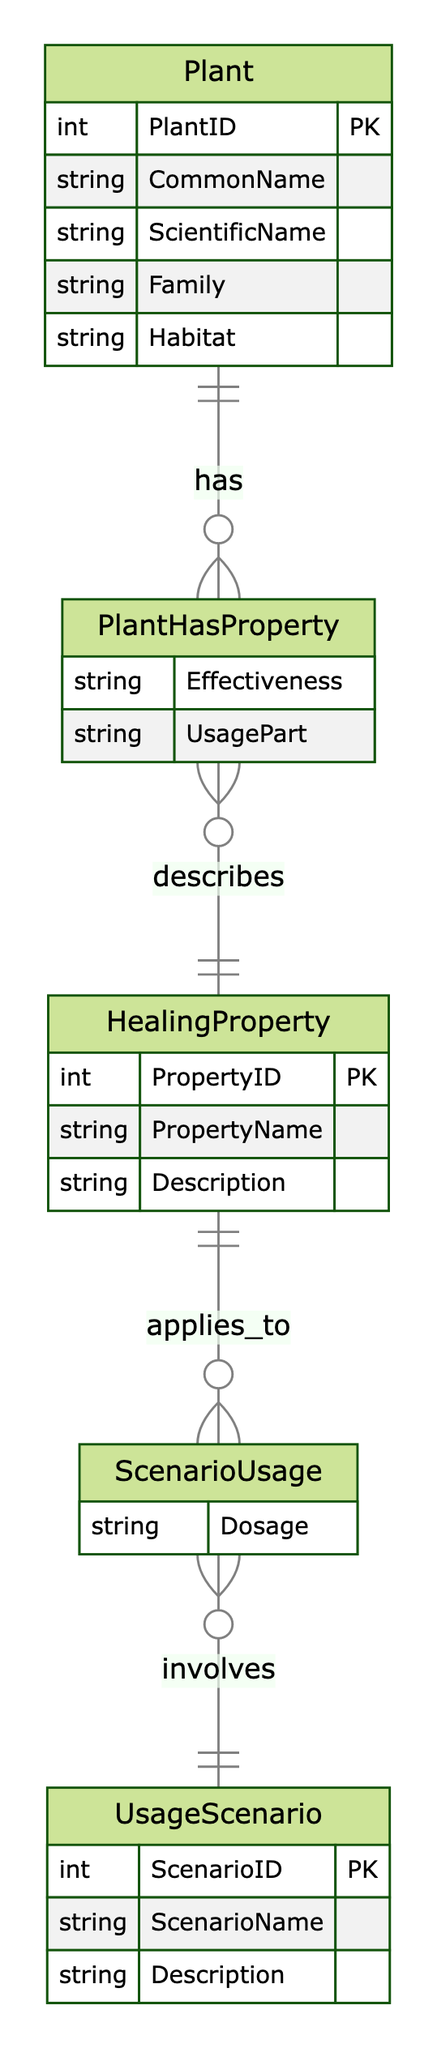What are the entities in this diagram? The diagram consists of four entities: Plant, HealingProperty, UsageScenario, and the associative entities PlantHasProperty and ScenarioUsage.
Answer: Plant, HealingProperty, UsageScenario, PlantHasProperty, ScenarioUsage How many attributes does the Plant entity have? The Plant entity contains five attributes: PlantID, CommonName, ScientificName, Family, and Habitat, which are listed under its definition.
Answer: Five What is the cardinality requirement between Plant and HealingProperty in the PlantHasProperty relationship? The diagram indicates that the Plant has a cardinality of "many" while HealingProperty also has a cardinality of "many". This means many plants can have many healing properties.
Answer: Many What additional attribute is included in the ScenarioUsage relationship? The ScenarioUsage relationship includes the attribute "Dosage," which specifies the dosage required in that scenario, reinforcing the usage of healing properties.
Answer: Dosage Which entity connects HealingProperty and UsageScenario? The relationship ScenarioUsage connects HealingProperty to UsageScenario, indicating that healing properties can be applied to various usage scenarios.
Answer: ScenarioUsage How many relationships are depicted in the diagram? There are two main relationships shown in the diagram: PlantHasProperty and ScenarioUsage, linking the entities together.
Answer: Two What type of information does the HealingProperty entity describe? The HealingProperty entity describes information about different healing properties, including their names and a description of what each property entails.
Answer: Healing properties Which entity is primarily responsible for detailing its effectiveness in the PlantHasProperty relationship? The PlantHasProperty relationship details the effectiveness of the Plant concerning the HealingProperty, highlighting the specific impact plants have on healing properties.
Answer: Plant Identify the cardinality between HealingProperty and UsageScenario in the ScenarioUsage relationship. In the ScenarioUsage relationship, both HealingProperty and UsageScenario are indicated to have cardinality "many," meaning multiple healing properties can apply to multiple usage scenarios.
Answer: Many 